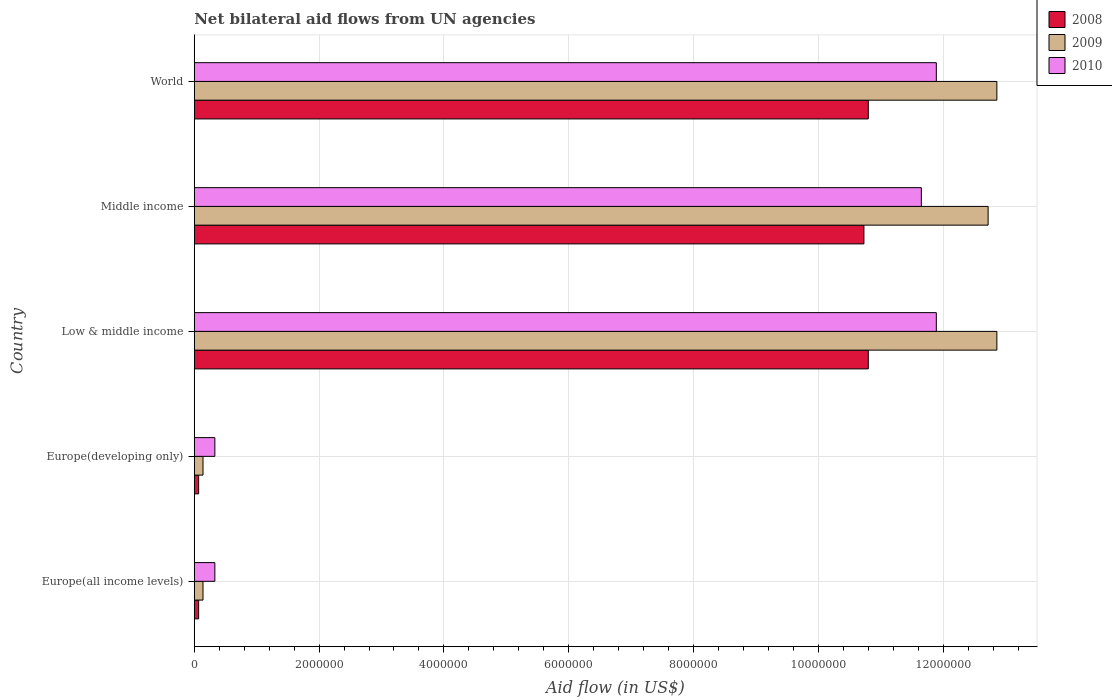How many different coloured bars are there?
Make the answer very short. 3. Are the number of bars per tick equal to the number of legend labels?
Provide a succinct answer. Yes. How many bars are there on the 5th tick from the top?
Give a very brief answer. 3. How many bars are there on the 2nd tick from the bottom?
Make the answer very short. 3. What is the net bilateral aid flow in 2010 in Low & middle income?
Give a very brief answer. 1.19e+07. Across all countries, what is the maximum net bilateral aid flow in 2009?
Offer a very short reply. 1.29e+07. Across all countries, what is the minimum net bilateral aid flow in 2010?
Make the answer very short. 3.30e+05. In which country was the net bilateral aid flow in 2008 minimum?
Offer a terse response. Europe(all income levels). What is the total net bilateral aid flow in 2009 in the graph?
Provide a short and direct response. 3.87e+07. What is the difference between the net bilateral aid flow in 2008 in Europe(all income levels) and that in World?
Your response must be concise. -1.07e+07. What is the difference between the net bilateral aid flow in 2009 in Middle income and the net bilateral aid flow in 2008 in Low & middle income?
Offer a terse response. 1.92e+06. What is the average net bilateral aid flow in 2008 per country?
Offer a terse response. 6.49e+06. What is the difference between the net bilateral aid flow in 2010 and net bilateral aid flow in 2009 in Low & middle income?
Keep it short and to the point. -9.70e+05. What is the ratio of the net bilateral aid flow in 2008 in Europe(developing only) to that in Middle income?
Offer a very short reply. 0.01. Is the net bilateral aid flow in 2008 in Middle income less than that in World?
Offer a terse response. Yes. Is the difference between the net bilateral aid flow in 2010 in Low & middle income and World greater than the difference between the net bilateral aid flow in 2009 in Low & middle income and World?
Provide a succinct answer. No. What is the difference between the highest and the second highest net bilateral aid flow in 2008?
Make the answer very short. 0. What is the difference between the highest and the lowest net bilateral aid flow in 2010?
Keep it short and to the point. 1.16e+07. In how many countries, is the net bilateral aid flow in 2010 greater than the average net bilateral aid flow in 2010 taken over all countries?
Offer a terse response. 3. What does the 1st bar from the bottom in Europe(developing only) represents?
Offer a terse response. 2008. How many bars are there?
Make the answer very short. 15. How many countries are there in the graph?
Provide a short and direct response. 5. Does the graph contain grids?
Your response must be concise. Yes. What is the title of the graph?
Make the answer very short. Net bilateral aid flows from UN agencies. Does "2011" appear as one of the legend labels in the graph?
Your response must be concise. No. What is the label or title of the X-axis?
Make the answer very short. Aid flow (in US$). What is the label or title of the Y-axis?
Your answer should be compact. Country. What is the Aid flow (in US$) in 2009 in Europe(all income levels)?
Your answer should be very brief. 1.40e+05. What is the Aid flow (in US$) in 2009 in Europe(developing only)?
Your answer should be very brief. 1.40e+05. What is the Aid flow (in US$) in 2008 in Low & middle income?
Your answer should be compact. 1.08e+07. What is the Aid flow (in US$) in 2009 in Low & middle income?
Give a very brief answer. 1.29e+07. What is the Aid flow (in US$) in 2010 in Low & middle income?
Make the answer very short. 1.19e+07. What is the Aid flow (in US$) of 2008 in Middle income?
Provide a succinct answer. 1.07e+07. What is the Aid flow (in US$) of 2009 in Middle income?
Ensure brevity in your answer.  1.27e+07. What is the Aid flow (in US$) of 2010 in Middle income?
Keep it short and to the point. 1.16e+07. What is the Aid flow (in US$) in 2008 in World?
Your response must be concise. 1.08e+07. What is the Aid flow (in US$) in 2009 in World?
Your answer should be very brief. 1.29e+07. What is the Aid flow (in US$) in 2010 in World?
Provide a succinct answer. 1.19e+07. Across all countries, what is the maximum Aid flow (in US$) of 2008?
Make the answer very short. 1.08e+07. Across all countries, what is the maximum Aid flow (in US$) in 2009?
Your answer should be very brief. 1.29e+07. Across all countries, what is the maximum Aid flow (in US$) in 2010?
Give a very brief answer. 1.19e+07. Across all countries, what is the minimum Aid flow (in US$) in 2009?
Keep it short and to the point. 1.40e+05. What is the total Aid flow (in US$) of 2008 in the graph?
Provide a succinct answer. 3.25e+07. What is the total Aid flow (in US$) in 2009 in the graph?
Offer a terse response. 3.87e+07. What is the total Aid flow (in US$) of 2010 in the graph?
Offer a very short reply. 3.61e+07. What is the difference between the Aid flow (in US$) in 2008 in Europe(all income levels) and that in Europe(developing only)?
Your answer should be compact. 0. What is the difference between the Aid flow (in US$) of 2009 in Europe(all income levels) and that in Europe(developing only)?
Your response must be concise. 0. What is the difference between the Aid flow (in US$) of 2010 in Europe(all income levels) and that in Europe(developing only)?
Give a very brief answer. 0. What is the difference between the Aid flow (in US$) in 2008 in Europe(all income levels) and that in Low & middle income?
Keep it short and to the point. -1.07e+07. What is the difference between the Aid flow (in US$) of 2009 in Europe(all income levels) and that in Low & middle income?
Offer a terse response. -1.27e+07. What is the difference between the Aid flow (in US$) of 2010 in Europe(all income levels) and that in Low & middle income?
Ensure brevity in your answer.  -1.16e+07. What is the difference between the Aid flow (in US$) in 2008 in Europe(all income levels) and that in Middle income?
Give a very brief answer. -1.07e+07. What is the difference between the Aid flow (in US$) in 2009 in Europe(all income levels) and that in Middle income?
Provide a succinct answer. -1.26e+07. What is the difference between the Aid flow (in US$) in 2010 in Europe(all income levels) and that in Middle income?
Your answer should be very brief. -1.13e+07. What is the difference between the Aid flow (in US$) in 2008 in Europe(all income levels) and that in World?
Your answer should be compact. -1.07e+07. What is the difference between the Aid flow (in US$) of 2009 in Europe(all income levels) and that in World?
Offer a very short reply. -1.27e+07. What is the difference between the Aid flow (in US$) of 2010 in Europe(all income levels) and that in World?
Provide a short and direct response. -1.16e+07. What is the difference between the Aid flow (in US$) of 2008 in Europe(developing only) and that in Low & middle income?
Ensure brevity in your answer.  -1.07e+07. What is the difference between the Aid flow (in US$) in 2009 in Europe(developing only) and that in Low & middle income?
Give a very brief answer. -1.27e+07. What is the difference between the Aid flow (in US$) in 2010 in Europe(developing only) and that in Low & middle income?
Provide a succinct answer. -1.16e+07. What is the difference between the Aid flow (in US$) of 2008 in Europe(developing only) and that in Middle income?
Provide a succinct answer. -1.07e+07. What is the difference between the Aid flow (in US$) of 2009 in Europe(developing only) and that in Middle income?
Your answer should be compact. -1.26e+07. What is the difference between the Aid flow (in US$) of 2010 in Europe(developing only) and that in Middle income?
Offer a terse response. -1.13e+07. What is the difference between the Aid flow (in US$) in 2008 in Europe(developing only) and that in World?
Keep it short and to the point. -1.07e+07. What is the difference between the Aid flow (in US$) in 2009 in Europe(developing only) and that in World?
Your answer should be very brief. -1.27e+07. What is the difference between the Aid flow (in US$) of 2010 in Europe(developing only) and that in World?
Ensure brevity in your answer.  -1.16e+07. What is the difference between the Aid flow (in US$) in 2010 in Low & middle income and that in Middle income?
Offer a terse response. 2.40e+05. What is the difference between the Aid flow (in US$) in 2009 in Low & middle income and that in World?
Keep it short and to the point. 0. What is the difference between the Aid flow (in US$) in 2010 in Low & middle income and that in World?
Give a very brief answer. 0. What is the difference between the Aid flow (in US$) of 2008 in Middle income and that in World?
Make the answer very short. -7.00e+04. What is the difference between the Aid flow (in US$) of 2009 in Middle income and that in World?
Your answer should be very brief. -1.40e+05. What is the difference between the Aid flow (in US$) in 2010 in Middle income and that in World?
Your response must be concise. -2.40e+05. What is the difference between the Aid flow (in US$) of 2008 in Europe(all income levels) and the Aid flow (in US$) of 2010 in Europe(developing only)?
Offer a very short reply. -2.60e+05. What is the difference between the Aid flow (in US$) of 2009 in Europe(all income levels) and the Aid flow (in US$) of 2010 in Europe(developing only)?
Provide a short and direct response. -1.90e+05. What is the difference between the Aid flow (in US$) in 2008 in Europe(all income levels) and the Aid flow (in US$) in 2009 in Low & middle income?
Provide a short and direct response. -1.28e+07. What is the difference between the Aid flow (in US$) of 2008 in Europe(all income levels) and the Aid flow (in US$) of 2010 in Low & middle income?
Your response must be concise. -1.18e+07. What is the difference between the Aid flow (in US$) of 2009 in Europe(all income levels) and the Aid flow (in US$) of 2010 in Low & middle income?
Make the answer very short. -1.18e+07. What is the difference between the Aid flow (in US$) of 2008 in Europe(all income levels) and the Aid flow (in US$) of 2009 in Middle income?
Provide a succinct answer. -1.26e+07. What is the difference between the Aid flow (in US$) of 2008 in Europe(all income levels) and the Aid flow (in US$) of 2010 in Middle income?
Give a very brief answer. -1.16e+07. What is the difference between the Aid flow (in US$) in 2009 in Europe(all income levels) and the Aid flow (in US$) in 2010 in Middle income?
Provide a short and direct response. -1.15e+07. What is the difference between the Aid flow (in US$) in 2008 in Europe(all income levels) and the Aid flow (in US$) in 2009 in World?
Keep it short and to the point. -1.28e+07. What is the difference between the Aid flow (in US$) in 2008 in Europe(all income levels) and the Aid flow (in US$) in 2010 in World?
Ensure brevity in your answer.  -1.18e+07. What is the difference between the Aid flow (in US$) in 2009 in Europe(all income levels) and the Aid flow (in US$) in 2010 in World?
Provide a succinct answer. -1.18e+07. What is the difference between the Aid flow (in US$) in 2008 in Europe(developing only) and the Aid flow (in US$) in 2009 in Low & middle income?
Your answer should be compact. -1.28e+07. What is the difference between the Aid flow (in US$) of 2008 in Europe(developing only) and the Aid flow (in US$) of 2010 in Low & middle income?
Your answer should be compact. -1.18e+07. What is the difference between the Aid flow (in US$) in 2009 in Europe(developing only) and the Aid flow (in US$) in 2010 in Low & middle income?
Offer a terse response. -1.18e+07. What is the difference between the Aid flow (in US$) of 2008 in Europe(developing only) and the Aid flow (in US$) of 2009 in Middle income?
Your answer should be compact. -1.26e+07. What is the difference between the Aid flow (in US$) in 2008 in Europe(developing only) and the Aid flow (in US$) in 2010 in Middle income?
Your response must be concise. -1.16e+07. What is the difference between the Aid flow (in US$) in 2009 in Europe(developing only) and the Aid flow (in US$) in 2010 in Middle income?
Your answer should be very brief. -1.15e+07. What is the difference between the Aid flow (in US$) in 2008 in Europe(developing only) and the Aid flow (in US$) in 2009 in World?
Keep it short and to the point. -1.28e+07. What is the difference between the Aid flow (in US$) in 2008 in Europe(developing only) and the Aid flow (in US$) in 2010 in World?
Offer a terse response. -1.18e+07. What is the difference between the Aid flow (in US$) of 2009 in Europe(developing only) and the Aid flow (in US$) of 2010 in World?
Make the answer very short. -1.18e+07. What is the difference between the Aid flow (in US$) in 2008 in Low & middle income and the Aid flow (in US$) in 2009 in Middle income?
Give a very brief answer. -1.92e+06. What is the difference between the Aid flow (in US$) in 2008 in Low & middle income and the Aid flow (in US$) in 2010 in Middle income?
Provide a succinct answer. -8.50e+05. What is the difference between the Aid flow (in US$) of 2009 in Low & middle income and the Aid flow (in US$) of 2010 in Middle income?
Provide a succinct answer. 1.21e+06. What is the difference between the Aid flow (in US$) of 2008 in Low & middle income and the Aid flow (in US$) of 2009 in World?
Offer a terse response. -2.06e+06. What is the difference between the Aid flow (in US$) of 2008 in Low & middle income and the Aid flow (in US$) of 2010 in World?
Give a very brief answer. -1.09e+06. What is the difference between the Aid flow (in US$) in 2009 in Low & middle income and the Aid flow (in US$) in 2010 in World?
Your answer should be compact. 9.70e+05. What is the difference between the Aid flow (in US$) of 2008 in Middle income and the Aid flow (in US$) of 2009 in World?
Your answer should be compact. -2.13e+06. What is the difference between the Aid flow (in US$) in 2008 in Middle income and the Aid flow (in US$) in 2010 in World?
Keep it short and to the point. -1.16e+06. What is the difference between the Aid flow (in US$) of 2009 in Middle income and the Aid flow (in US$) of 2010 in World?
Offer a terse response. 8.30e+05. What is the average Aid flow (in US$) of 2008 per country?
Your answer should be very brief. 6.49e+06. What is the average Aid flow (in US$) in 2009 per country?
Provide a succinct answer. 7.74e+06. What is the average Aid flow (in US$) of 2010 per country?
Offer a terse response. 7.22e+06. What is the difference between the Aid flow (in US$) of 2009 and Aid flow (in US$) of 2010 in Europe(all income levels)?
Your answer should be very brief. -1.90e+05. What is the difference between the Aid flow (in US$) in 2008 and Aid flow (in US$) in 2009 in Europe(developing only)?
Offer a very short reply. -7.00e+04. What is the difference between the Aid flow (in US$) of 2008 and Aid flow (in US$) of 2009 in Low & middle income?
Provide a succinct answer. -2.06e+06. What is the difference between the Aid flow (in US$) in 2008 and Aid flow (in US$) in 2010 in Low & middle income?
Provide a succinct answer. -1.09e+06. What is the difference between the Aid flow (in US$) in 2009 and Aid flow (in US$) in 2010 in Low & middle income?
Your response must be concise. 9.70e+05. What is the difference between the Aid flow (in US$) of 2008 and Aid flow (in US$) of 2009 in Middle income?
Offer a terse response. -1.99e+06. What is the difference between the Aid flow (in US$) in 2008 and Aid flow (in US$) in 2010 in Middle income?
Offer a terse response. -9.20e+05. What is the difference between the Aid flow (in US$) in 2009 and Aid flow (in US$) in 2010 in Middle income?
Ensure brevity in your answer.  1.07e+06. What is the difference between the Aid flow (in US$) in 2008 and Aid flow (in US$) in 2009 in World?
Give a very brief answer. -2.06e+06. What is the difference between the Aid flow (in US$) in 2008 and Aid flow (in US$) in 2010 in World?
Offer a very short reply. -1.09e+06. What is the difference between the Aid flow (in US$) in 2009 and Aid flow (in US$) in 2010 in World?
Provide a short and direct response. 9.70e+05. What is the ratio of the Aid flow (in US$) of 2008 in Europe(all income levels) to that in Low & middle income?
Your answer should be very brief. 0.01. What is the ratio of the Aid flow (in US$) of 2009 in Europe(all income levels) to that in Low & middle income?
Provide a succinct answer. 0.01. What is the ratio of the Aid flow (in US$) of 2010 in Europe(all income levels) to that in Low & middle income?
Your answer should be compact. 0.03. What is the ratio of the Aid flow (in US$) in 2008 in Europe(all income levels) to that in Middle income?
Provide a short and direct response. 0.01. What is the ratio of the Aid flow (in US$) in 2009 in Europe(all income levels) to that in Middle income?
Your answer should be compact. 0.01. What is the ratio of the Aid flow (in US$) in 2010 in Europe(all income levels) to that in Middle income?
Make the answer very short. 0.03. What is the ratio of the Aid flow (in US$) of 2008 in Europe(all income levels) to that in World?
Make the answer very short. 0.01. What is the ratio of the Aid flow (in US$) in 2009 in Europe(all income levels) to that in World?
Offer a terse response. 0.01. What is the ratio of the Aid flow (in US$) of 2010 in Europe(all income levels) to that in World?
Your answer should be compact. 0.03. What is the ratio of the Aid flow (in US$) of 2008 in Europe(developing only) to that in Low & middle income?
Offer a very short reply. 0.01. What is the ratio of the Aid flow (in US$) of 2009 in Europe(developing only) to that in Low & middle income?
Offer a very short reply. 0.01. What is the ratio of the Aid flow (in US$) of 2010 in Europe(developing only) to that in Low & middle income?
Your response must be concise. 0.03. What is the ratio of the Aid flow (in US$) in 2008 in Europe(developing only) to that in Middle income?
Your answer should be compact. 0.01. What is the ratio of the Aid flow (in US$) of 2009 in Europe(developing only) to that in Middle income?
Your answer should be compact. 0.01. What is the ratio of the Aid flow (in US$) in 2010 in Europe(developing only) to that in Middle income?
Make the answer very short. 0.03. What is the ratio of the Aid flow (in US$) of 2008 in Europe(developing only) to that in World?
Your answer should be compact. 0.01. What is the ratio of the Aid flow (in US$) in 2009 in Europe(developing only) to that in World?
Your response must be concise. 0.01. What is the ratio of the Aid flow (in US$) in 2010 in Europe(developing only) to that in World?
Ensure brevity in your answer.  0.03. What is the ratio of the Aid flow (in US$) of 2008 in Low & middle income to that in Middle income?
Your answer should be very brief. 1.01. What is the ratio of the Aid flow (in US$) of 2009 in Low & middle income to that in Middle income?
Your answer should be very brief. 1.01. What is the ratio of the Aid flow (in US$) in 2010 in Low & middle income to that in Middle income?
Give a very brief answer. 1.02. What is the ratio of the Aid flow (in US$) of 2008 in Low & middle income to that in World?
Make the answer very short. 1. What is the ratio of the Aid flow (in US$) of 2009 in Low & middle income to that in World?
Your answer should be very brief. 1. What is the ratio of the Aid flow (in US$) of 2008 in Middle income to that in World?
Give a very brief answer. 0.99. What is the ratio of the Aid flow (in US$) in 2010 in Middle income to that in World?
Provide a short and direct response. 0.98. What is the difference between the highest and the second highest Aid flow (in US$) in 2008?
Provide a short and direct response. 0. What is the difference between the highest and the lowest Aid flow (in US$) of 2008?
Keep it short and to the point. 1.07e+07. What is the difference between the highest and the lowest Aid flow (in US$) in 2009?
Ensure brevity in your answer.  1.27e+07. What is the difference between the highest and the lowest Aid flow (in US$) of 2010?
Offer a very short reply. 1.16e+07. 